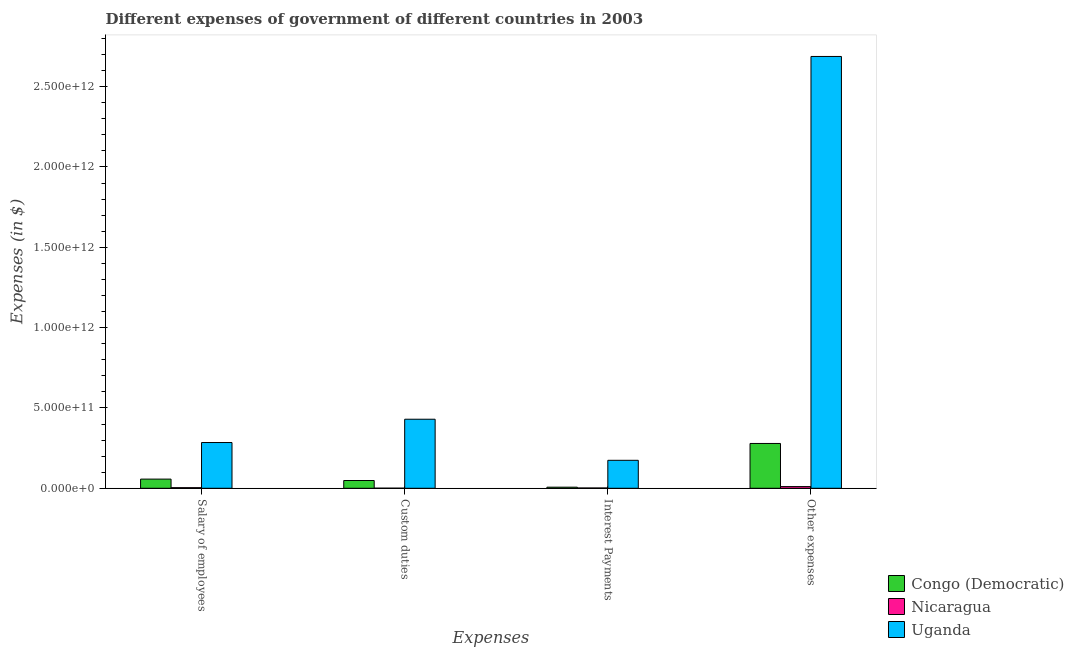Are the number of bars per tick equal to the number of legend labels?
Your answer should be compact. Yes. Are the number of bars on each tick of the X-axis equal?
Make the answer very short. Yes. What is the label of the 2nd group of bars from the left?
Your response must be concise. Custom duties. What is the amount spent on interest payments in Nicaragua?
Provide a short and direct response. 1.92e+09. Across all countries, what is the maximum amount spent on custom duties?
Keep it short and to the point. 4.30e+11. Across all countries, what is the minimum amount spent on interest payments?
Give a very brief answer. 1.92e+09. In which country was the amount spent on other expenses maximum?
Give a very brief answer. Uganda. In which country was the amount spent on salary of employees minimum?
Offer a very short reply. Nicaragua. What is the total amount spent on custom duties in the graph?
Your response must be concise. 4.79e+11. What is the difference between the amount spent on other expenses in Nicaragua and that in Uganda?
Provide a short and direct response. -2.68e+12. What is the difference between the amount spent on salary of employees in Nicaragua and the amount spent on other expenses in Uganda?
Offer a very short reply. -2.68e+12. What is the average amount spent on interest payments per country?
Offer a terse response. 6.10e+1. What is the difference between the amount spent on salary of employees and amount spent on custom duties in Nicaragua?
Make the answer very short. 3.21e+09. What is the ratio of the amount spent on custom duties in Nicaragua to that in Uganda?
Your answer should be compact. 0. Is the amount spent on other expenses in Congo (Democratic) less than that in Nicaragua?
Your answer should be very brief. No. What is the difference between the highest and the second highest amount spent on salary of employees?
Offer a very short reply. 2.28e+11. What is the difference between the highest and the lowest amount spent on interest payments?
Ensure brevity in your answer.  1.72e+11. In how many countries, is the amount spent on other expenses greater than the average amount spent on other expenses taken over all countries?
Your answer should be compact. 1. Is the sum of the amount spent on salary of employees in Congo (Democratic) and Nicaragua greater than the maximum amount spent on interest payments across all countries?
Keep it short and to the point. No. Is it the case that in every country, the sum of the amount spent on other expenses and amount spent on salary of employees is greater than the sum of amount spent on interest payments and amount spent on custom duties?
Provide a succinct answer. No. What does the 1st bar from the left in Interest Payments represents?
Offer a terse response. Congo (Democratic). What does the 1st bar from the right in Salary of employees represents?
Your response must be concise. Uganda. How many bars are there?
Ensure brevity in your answer.  12. Are all the bars in the graph horizontal?
Keep it short and to the point. No. What is the difference between two consecutive major ticks on the Y-axis?
Provide a succinct answer. 5.00e+11. Does the graph contain grids?
Make the answer very short. No. How are the legend labels stacked?
Your answer should be very brief. Vertical. What is the title of the graph?
Ensure brevity in your answer.  Different expenses of government of different countries in 2003. Does "Upper middle income" appear as one of the legend labels in the graph?
Make the answer very short. No. What is the label or title of the X-axis?
Give a very brief answer. Expenses. What is the label or title of the Y-axis?
Keep it short and to the point. Expenses (in $). What is the Expenses (in $) in Congo (Democratic) in Salary of employees?
Provide a short and direct response. 5.71e+1. What is the Expenses (in $) in Nicaragua in Salary of employees?
Ensure brevity in your answer.  3.83e+09. What is the Expenses (in $) in Uganda in Salary of employees?
Ensure brevity in your answer.  2.85e+11. What is the Expenses (in $) in Congo (Democratic) in Custom duties?
Keep it short and to the point. 4.84e+1. What is the Expenses (in $) in Nicaragua in Custom duties?
Keep it short and to the point. 6.28e+08. What is the Expenses (in $) of Uganda in Custom duties?
Your answer should be compact. 4.30e+11. What is the Expenses (in $) in Congo (Democratic) in Interest Payments?
Your answer should be very brief. 6.88e+09. What is the Expenses (in $) of Nicaragua in Interest Payments?
Make the answer very short. 1.92e+09. What is the Expenses (in $) in Uganda in Interest Payments?
Offer a very short reply. 1.74e+11. What is the Expenses (in $) in Congo (Democratic) in Other expenses?
Your response must be concise. 2.79e+11. What is the Expenses (in $) of Nicaragua in Other expenses?
Ensure brevity in your answer.  1.06e+1. What is the Expenses (in $) of Uganda in Other expenses?
Your response must be concise. 2.69e+12. Across all Expenses, what is the maximum Expenses (in $) in Congo (Democratic)?
Keep it short and to the point. 2.79e+11. Across all Expenses, what is the maximum Expenses (in $) of Nicaragua?
Provide a succinct answer. 1.06e+1. Across all Expenses, what is the maximum Expenses (in $) in Uganda?
Your answer should be compact. 2.69e+12. Across all Expenses, what is the minimum Expenses (in $) in Congo (Democratic)?
Offer a terse response. 6.88e+09. Across all Expenses, what is the minimum Expenses (in $) in Nicaragua?
Ensure brevity in your answer.  6.28e+08. Across all Expenses, what is the minimum Expenses (in $) in Uganda?
Keep it short and to the point. 1.74e+11. What is the total Expenses (in $) of Congo (Democratic) in the graph?
Give a very brief answer. 3.91e+11. What is the total Expenses (in $) in Nicaragua in the graph?
Your answer should be compact. 1.70e+1. What is the total Expenses (in $) in Uganda in the graph?
Offer a very short reply. 3.58e+12. What is the difference between the Expenses (in $) in Congo (Democratic) in Salary of employees and that in Custom duties?
Your answer should be very brief. 8.69e+09. What is the difference between the Expenses (in $) of Nicaragua in Salary of employees and that in Custom duties?
Your response must be concise. 3.21e+09. What is the difference between the Expenses (in $) of Uganda in Salary of employees and that in Custom duties?
Offer a terse response. -1.45e+11. What is the difference between the Expenses (in $) of Congo (Democratic) in Salary of employees and that in Interest Payments?
Provide a short and direct response. 5.02e+1. What is the difference between the Expenses (in $) in Nicaragua in Salary of employees and that in Interest Payments?
Provide a succinct answer. 1.92e+09. What is the difference between the Expenses (in $) of Uganda in Salary of employees and that in Interest Payments?
Provide a succinct answer. 1.11e+11. What is the difference between the Expenses (in $) of Congo (Democratic) in Salary of employees and that in Other expenses?
Your answer should be compact. -2.22e+11. What is the difference between the Expenses (in $) in Nicaragua in Salary of employees and that in Other expenses?
Your response must be concise. -6.74e+09. What is the difference between the Expenses (in $) in Uganda in Salary of employees and that in Other expenses?
Provide a succinct answer. -2.40e+12. What is the difference between the Expenses (in $) of Congo (Democratic) in Custom duties and that in Interest Payments?
Make the answer very short. 4.15e+1. What is the difference between the Expenses (in $) of Nicaragua in Custom duties and that in Interest Payments?
Offer a very short reply. -1.29e+09. What is the difference between the Expenses (in $) in Uganda in Custom duties and that in Interest Payments?
Your response must be concise. 2.56e+11. What is the difference between the Expenses (in $) in Congo (Democratic) in Custom duties and that in Other expenses?
Give a very brief answer. -2.31e+11. What is the difference between the Expenses (in $) of Nicaragua in Custom duties and that in Other expenses?
Make the answer very short. -9.95e+09. What is the difference between the Expenses (in $) in Uganda in Custom duties and that in Other expenses?
Keep it short and to the point. -2.26e+12. What is the difference between the Expenses (in $) of Congo (Democratic) in Interest Payments and that in Other expenses?
Make the answer very short. -2.72e+11. What is the difference between the Expenses (in $) of Nicaragua in Interest Payments and that in Other expenses?
Offer a very short reply. -8.65e+09. What is the difference between the Expenses (in $) of Uganda in Interest Payments and that in Other expenses?
Give a very brief answer. -2.51e+12. What is the difference between the Expenses (in $) of Congo (Democratic) in Salary of employees and the Expenses (in $) of Nicaragua in Custom duties?
Keep it short and to the point. 5.65e+1. What is the difference between the Expenses (in $) in Congo (Democratic) in Salary of employees and the Expenses (in $) in Uganda in Custom duties?
Give a very brief answer. -3.73e+11. What is the difference between the Expenses (in $) in Nicaragua in Salary of employees and the Expenses (in $) in Uganda in Custom duties?
Your response must be concise. -4.26e+11. What is the difference between the Expenses (in $) in Congo (Democratic) in Salary of employees and the Expenses (in $) in Nicaragua in Interest Payments?
Offer a terse response. 5.52e+1. What is the difference between the Expenses (in $) of Congo (Democratic) in Salary of employees and the Expenses (in $) of Uganda in Interest Payments?
Your answer should be compact. -1.17e+11. What is the difference between the Expenses (in $) in Nicaragua in Salary of employees and the Expenses (in $) in Uganda in Interest Payments?
Give a very brief answer. -1.70e+11. What is the difference between the Expenses (in $) of Congo (Democratic) in Salary of employees and the Expenses (in $) of Nicaragua in Other expenses?
Give a very brief answer. 4.65e+1. What is the difference between the Expenses (in $) in Congo (Democratic) in Salary of employees and the Expenses (in $) in Uganda in Other expenses?
Give a very brief answer. -2.63e+12. What is the difference between the Expenses (in $) of Nicaragua in Salary of employees and the Expenses (in $) of Uganda in Other expenses?
Provide a succinct answer. -2.68e+12. What is the difference between the Expenses (in $) in Congo (Democratic) in Custom duties and the Expenses (in $) in Nicaragua in Interest Payments?
Ensure brevity in your answer.  4.65e+1. What is the difference between the Expenses (in $) in Congo (Democratic) in Custom duties and the Expenses (in $) in Uganda in Interest Payments?
Offer a terse response. -1.26e+11. What is the difference between the Expenses (in $) of Nicaragua in Custom duties and the Expenses (in $) of Uganda in Interest Payments?
Ensure brevity in your answer.  -1.73e+11. What is the difference between the Expenses (in $) in Congo (Democratic) in Custom duties and the Expenses (in $) in Nicaragua in Other expenses?
Your answer should be compact. 3.78e+1. What is the difference between the Expenses (in $) in Congo (Democratic) in Custom duties and the Expenses (in $) in Uganda in Other expenses?
Keep it short and to the point. -2.64e+12. What is the difference between the Expenses (in $) in Nicaragua in Custom duties and the Expenses (in $) in Uganda in Other expenses?
Ensure brevity in your answer.  -2.69e+12. What is the difference between the Expenses (in $) in Congo (Democratic) in Interest Payments and the Expenses (in $) in Nicaragua in Other expenses?
Your response must be concise. -3.70e+09. What is the difference between the Expenses (in $) of Congo (Democratic) in Interest Payments and the Expenses (in $) of Uganda in Other expenses?
Provide a succinct answer. -2.68e+12. What is the difference between the Expenses (in $) of Nicaragua in Interest Payments and the Expenses (in $) of Uganda in Other expenses?
Give a very brief answer. -2.69e+12. What is the average Expenses (in $) in Congo (Democratic) per Expenses?
Offer a terse response. 9.78e+1. What is the average Expenses (in $) in Nicaragua per Expenses?
Keep it short and to the point. 4.24e+09. What is the average Expenses (in $) in Uganda per Expenses?
Provide a short and direct response. 8.94e+11. What is the difference between the Expenses (in $) in Congo (Democratic) and Expenses (in $) in Nicaragua in Salary of employees?
Provide a short and direct response. 5.33e+1. What is the difference between the Expenses (in $) in Congo (Democratic) and Expenses (in $) in Uganda in Salary of employees?
Your response must be concise. -2.28e+11. What is the difference between the Expenses (in $) of Nicaragua and Expenses (in $) of Uganda in Salary of employees?
Offer a terse response. -2.81e+11. What is the difference between the Expenses (in $) in Congo (Democratic) and Expenses (in $) in Nicaragua in Custom duties?
Your answer should be very brief. 4.78e+1. What is the difference between the Expenses (in $) of Congo (Democratic) and Expenses (in $) of Uganda in Custom duties?
Provide a succinct answer. -3.81e+11. What is the difference between the Expenses (in $) in Nicaragua and Expenses (in $) in Uganda in Custom duties?
Your response must be concise. -4.29e+11. What is the difference between the Expenses (in $) in Congo (Democratic) and Expenses (in $) in Nicaragua in Interest Payments?
Make the answer very short. 4.96e+09. What is the difference between the Expenses (in $) in Congo (Democratic) and Expenses (in $) in Uganda in Interest Payments?
Offer a very short reply. -1.67e+11. What is the difference between the Expenses (in $) in Nicaragua and Expenses (in $) in Uganda in Interest Payments?
Offer a terse response. -1.72e+11. What is the difference between the Expenses (in $) of Congo (Democratic) and Expenses (in $) of Nicaragua in Other expenses?
Your answer should be compact. 2.68e+11. What is the difference between the Expenses (in $) of Congo (Democratic) and Expenses (in $) of Uganda in Other expenses?
Provide a succinct answer. -2.41e+12. What is the difference between the Expenses (in $) of Nicaragua and Expenses (in $) of Uganda in Other expenses?
Your response must be concise. -2.68e+12. What is the ratio of the Expenses (in $) in Congo (Democratic) in Salary of employees to that in Custom duties?
Keep it short and to the point. 1.18. What is the ratio of the Expenses (in $) in Nicaragua in Salary of employees to that in Custom duties?
Offer a terse response. 6.1. What is the ratio of the Expenses (in $) in Uganda in Salary of employees to that in Custom duties?
Give a very brief answer. 0.66. What is the ratio of the Expenses (in $) of Congo (Democratic) in Salary of employees to that in Interest Payments?
Provide a short and direct response. 8.31. What is the ratio of the Expenses (in $) of Nicaragua in Salary of employees to that in Interest Payments?
Keep it short and to the point. 2. What is the ratio of the Expenses (in $) of Uganda in Salary of employees to that in Interest Payments?
Your answer should be compact. 1.64. What is the ratio of the Expenses (in $) of Congo (Democratic) in Salary of employees to that in Other expenses?
Your answer should be compact. 0.2. What is the ratio of the Expenses (in $) of Nicaragua in Salary of employees to that in Other expenses?
Provide a succinct answer. 0.36. What is the ratio of the Expenses (in $) in Uganda in Salary of employees to that in Other expenses?
Give a very brief answer. 0.11. What is the ratio of the Expenses (in $) of Congo (Democratic) in Custom duties to that in Interest Payments?
Offer a very short reply. 7.04. What is the ratio of the Expenses (in $) of Nicaragua in Custom duties to that in Interest Payments?
Your answer should be compact. 0.33. What is the ratio of the Expenses (in $) of Uganda in Custom duties to that in Interest Payments?
Your response must be concise. 2.47. What is the ratio of the Expenses (in $) of Congo (Democratic) in Custom duties to that in Other expenses?
Offer a terse response. 0.17. What is the ratio of the Expenses (in $) in Nicaragua in Custom duties to that in Other expenses?
Give a very brief answer. 0.06. What is the ratio of the Expenses (in $) of Uganda in Custom duties to that in Other expenses?
Provide a short and direct response. 0.16. What is the ratio of the Expenses (in $) of Congo (Democratic) in Interest Payments to that in Other expenses?
Your response must be concise. 0.02. What is the ratio of the Expenses (in $) of Nicaragua in Interest Payments to that in Other expenses?
Provide a short and direct response. 0.18. What is the ratio of the Expenses (in $) in Uganda in Interest Payments to that in Other expenses?
Give a very brief answer. 0.06. What is the difference between the highest and the second highest Expenses (in $) of Congo (Democratic)?
Make the answer very short. 2.22e+11. What is the difference between the highest and the second highest Expenses (in $) of Nicaragua?
Your response must be concise. 6.74e+09. What is the difference between the highest and the second highest Expenses (in $) in Uganda?
Your answer should be very brief. 2.26e+12. What is the difference between the highest and the lowest Expenses (in $) in Congo (Democratic)?
Your answer should be compact. 2.72e+11. What is the difference between the highest and the lowest Expenses (in $) in Nicaragua?
Offer a very short reply. 9.95e+09. What is the difference between the highest and the lowest Expenses (in $) in Uganda?
Provide a succinct answer. 2.51e+12. 